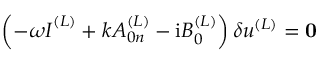Convert formula to latex. <formula><loc_0><loc_0><loc_500><loc_500>\left ( - \omega I ^ { ( L ) } + k A _ { 0 n } ^ { ( L ) } - { i } B _ { 0 } ^ { ( L ) } \right ) \delta u ^ { ( L ) } = { 0 }</formula> 